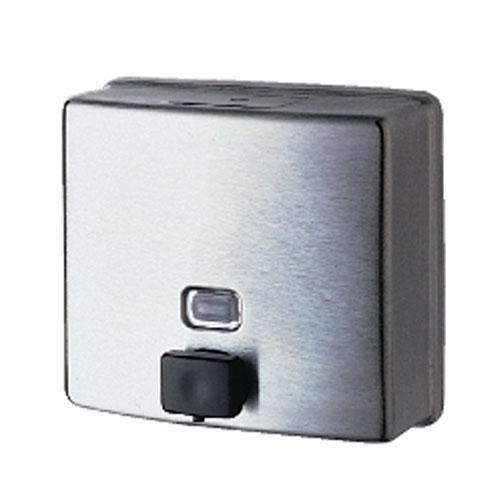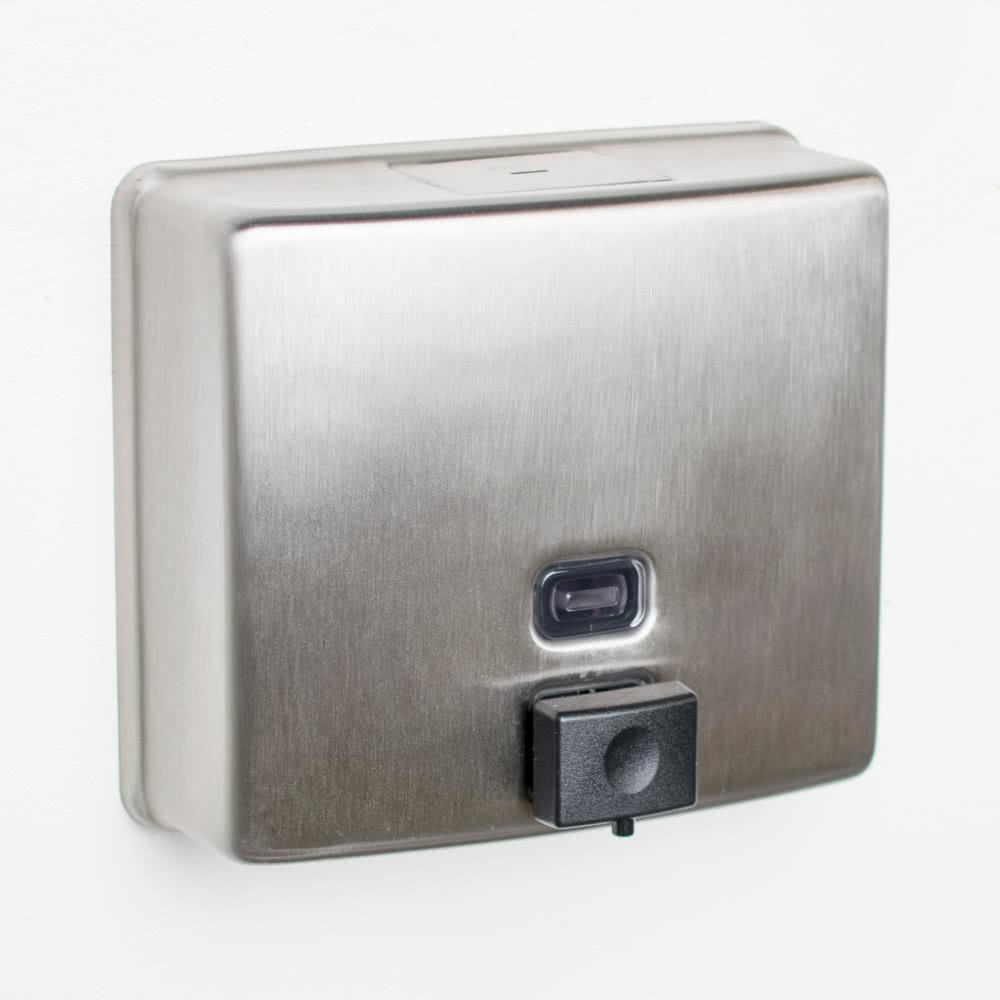The first image is the image on the left, the second image is the image on the right. Examine the images to the left and right. Is the description "The dispenser on the left has a chrome push-button that extends out, and the dispenser on the right has a flat black rectangular button." accurate? Answer yes or no. No. The first image is the image on the left, the second image is the image on the right. For the images shown, is this caption "The left and right image contains the same number of metal square soap dispenser." true? Answer yes or no. Yes. 